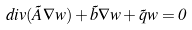Convert formula to latex. <formula><loc_0><loc_0><loc_500><loc_500>d i v ( \tilde { A } \nabla w ) + \tilde { b } \nabla w + \tilde { q } w = 0</formula> 